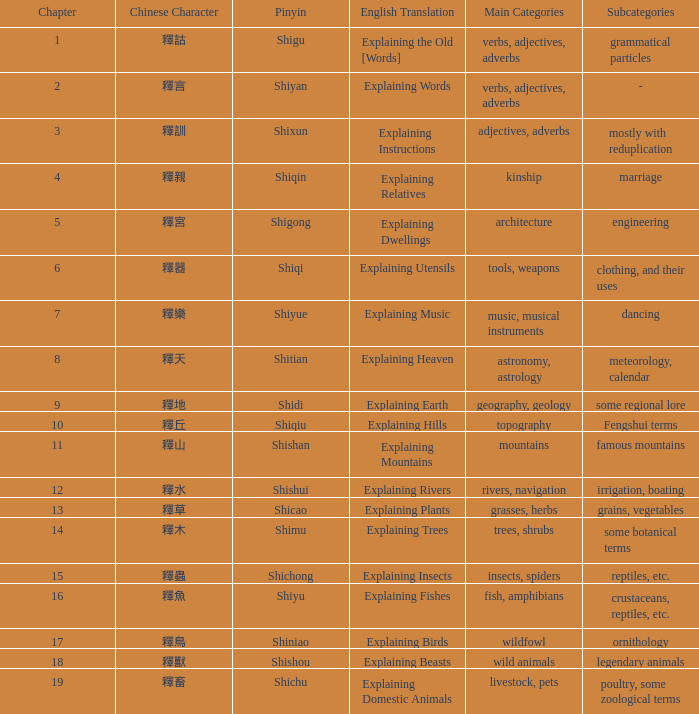Could you help me parse every detail presented in this table? {'header': ['Chapter', 'Chinese Character', 'Pinyin', 'English Translation', 'Main Categories', 'Subcategories'], 'rows': [['1', '釋詁', 'Shigu', 'Explaining the Old [Words]', 'verbs, adjectives, adverbs', 'grammatical particles'], ['2', '釋言', 'Shiyan', 'Explaining Words', 'verbs, adjectives, adverbs', '-'], ['3', '釋訓', 'Shixun', 'Explaining Instructions', 'adjectives, adverbs', 'mostly with reduplication'], ['4', '釋親', 'Shiqin', 'Explaining Relatives', 'kinship', 'marriage'], ['5', '釋宮', 'Shigong', 'Explaining Dwellings', 'architecture', 'engineering'], ['6', '釋器', 'Shiqi', 'Explaining Utensils', 'tools, weapons', 'clothing, and their uses'], ['7', '釋樂', 'Shiyue', 'Explaining Music', 'music, musical instruments', 'dancing'], ['8', '釋天', 'Shitian', 'Explaining Heaven', 'astronomy, astrology', 'meteorology, calendar'], ['9', '釋地', 'Shidi', 'Explaining Earth', 'geography, geology', 'some regional lore'], ['10', '釋丘', 'Shiqiu', 'Explaining Hills', 'topography', 'Fengshui terms'], ['11', '釋山', 'Shishan', 'Explaining Mountains', 'mountains', 'famous mountains'], ['12', '釋水', 'Shishui', 'Explaining Rivers', 'rivers, navigation', 'irrigation, boating'], ['13', '釋草', 'Shicao', 'Explaining Plants', 'grasses, herbs', 'grains, vegetables'], ['14', '釋木', 'Shimu', 'Explaining Trees', 'trees, shrubs', 'some botanical terms'], ['15', '釋蟲', 'Shichong', 'Explaining Insects', 'insects, spiders', 'reptiles, etc.'], ['16', '釋魚', 'Shiyu', 'Explaining Fishes', 'fish, amphibians', 'crustaceans, reptiles, etc.'], ['17', '釋鳥', 'Shiniao', 'Explaining Birds', 'wildfowl', 'ornithology'], ['18', '釋獸', 'Shishou', 'Explaining Beasts', 'wild animals', 'legendary animals'], ['19', '釋畜', 'Shichu', 'Explaining Domestic Animals', 'livestock, pets', 'poultry, some zoological terms']]} Name the highest chapter with chinese of 釋言 2.0. 